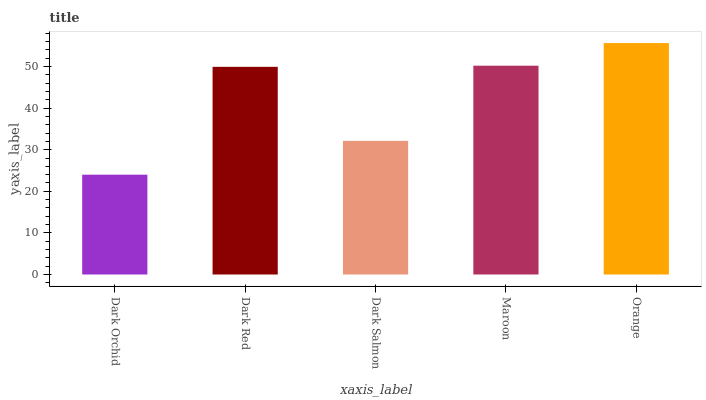Is Dark Red the minimum?
Answer yes or no. No. Is Dark Red the maximum?
Answer yes or no. No. Is Dark Red greater than Dark Orchid?
Answer yes or no. Yes. Is Dark Orchid less than Dark Red?
Answer yes or no. Yes. Is Dark Orchid greater than Dark Red?
Answer yes or no. No. Is Dark Red less than Dark Orchid?
Answer yes or no. No. Is Dark Red the high median?
Answer yes or no. Yes. Is Dark Red the low median?
Answer yes or no. Yes. Is Dark Orchid the high median?
Answer yes or no. No. Is Dark Orchid the low median?
Answer yes or no. No. 